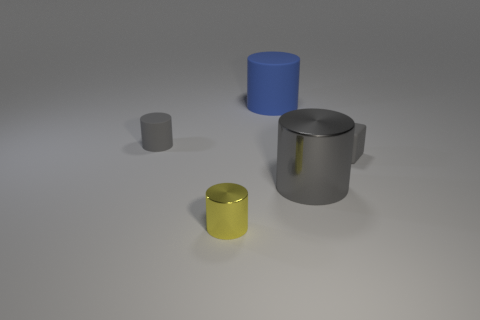Add 1 gray blocks. How many objects exist? 6 Subtract all blocks. How many objects are left? 4 Add 1 tiny metallic cylinders. How many tiny metallic cylinders are left? 2 Add 4 gray matte cylinders. How many gray matte cylinders exist? 5 Subtract 0 blue cubes. How many objects are left? 5 Subtract all large red metal cylinders. Subtract all tiny gray objects. How many objects are left? 3 